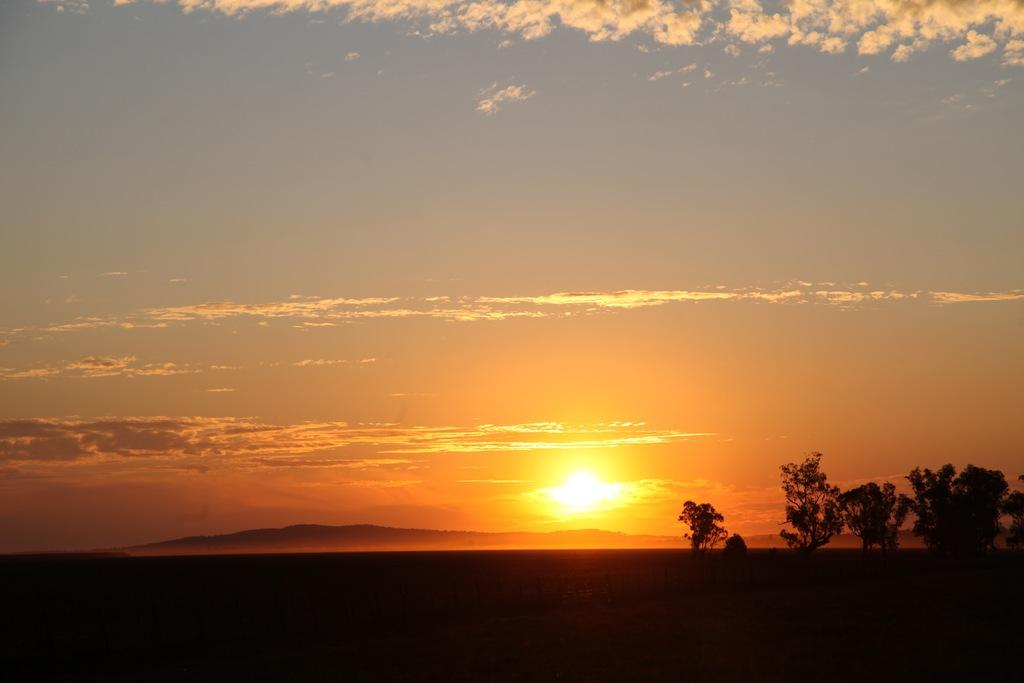What type of vegetation can be seen on the land in the image? There are trees on the land in the image. What is visible at the top of the image? The sky is visible at the top of the image. What can be seen in the sky? There are clouds and the sun visible in the sky. What is the weight of the cracker floating in the sky? There is no cracker present in the image, and therefore no weight can be determined. 